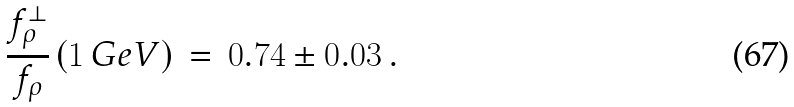Convert formula to latex. <formula><loc_0><loc_0><loc_500><loc_500>\frac { f _ { \rho } ^ { \perp } } { f _ { \rho } } \left ( 1 \, G e V \right ) \, = \, 0 . 7 4 \pm 0 . 0 3 \, .</formula> 